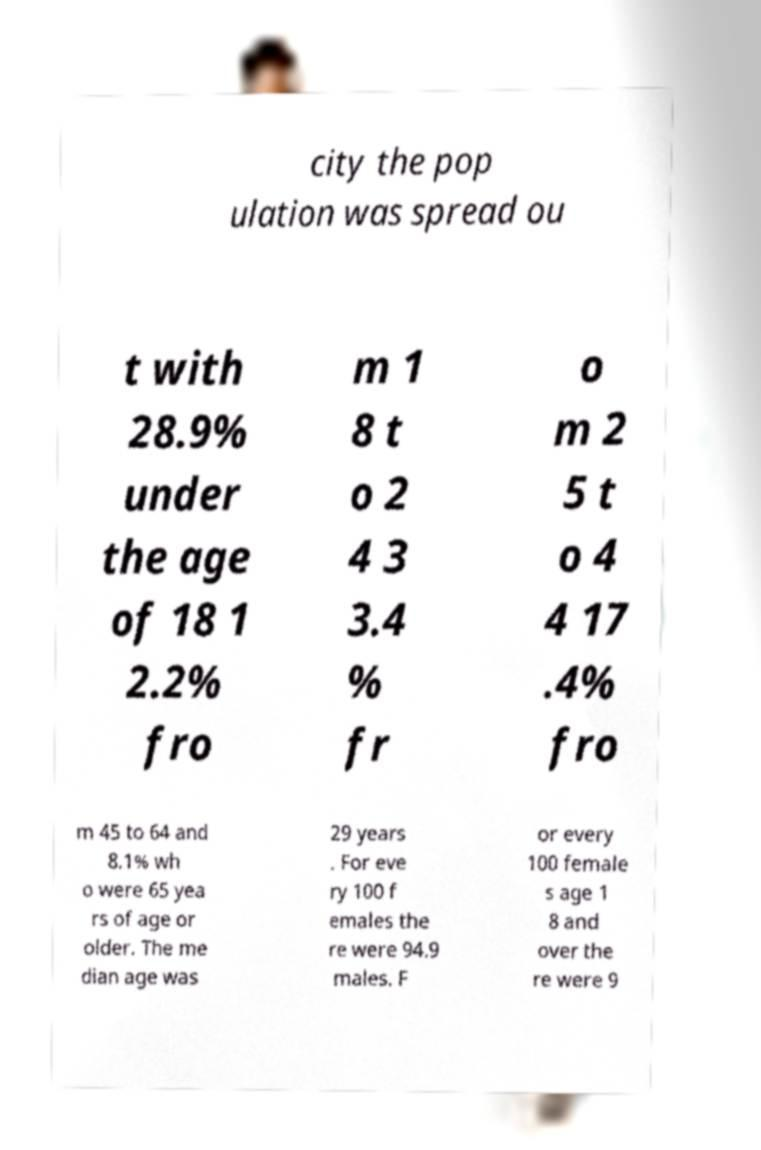Please identify and transcribe the text found in this image. city the pop ulation was spread ou t with 28.9% under the age of 18 1 2.2% fro m 1 8 t o 2 4 3 3.4 % fr o m 2 5 t o 4 4 17 .4% fro m 45 to 64 and 8.1% wh o were 65 yea rs of age or older. The me dian age was 29 years . For eve ry 100 f emales the re were 94.9 males. F or every 100 female s age 1 8 and over the re were 9 